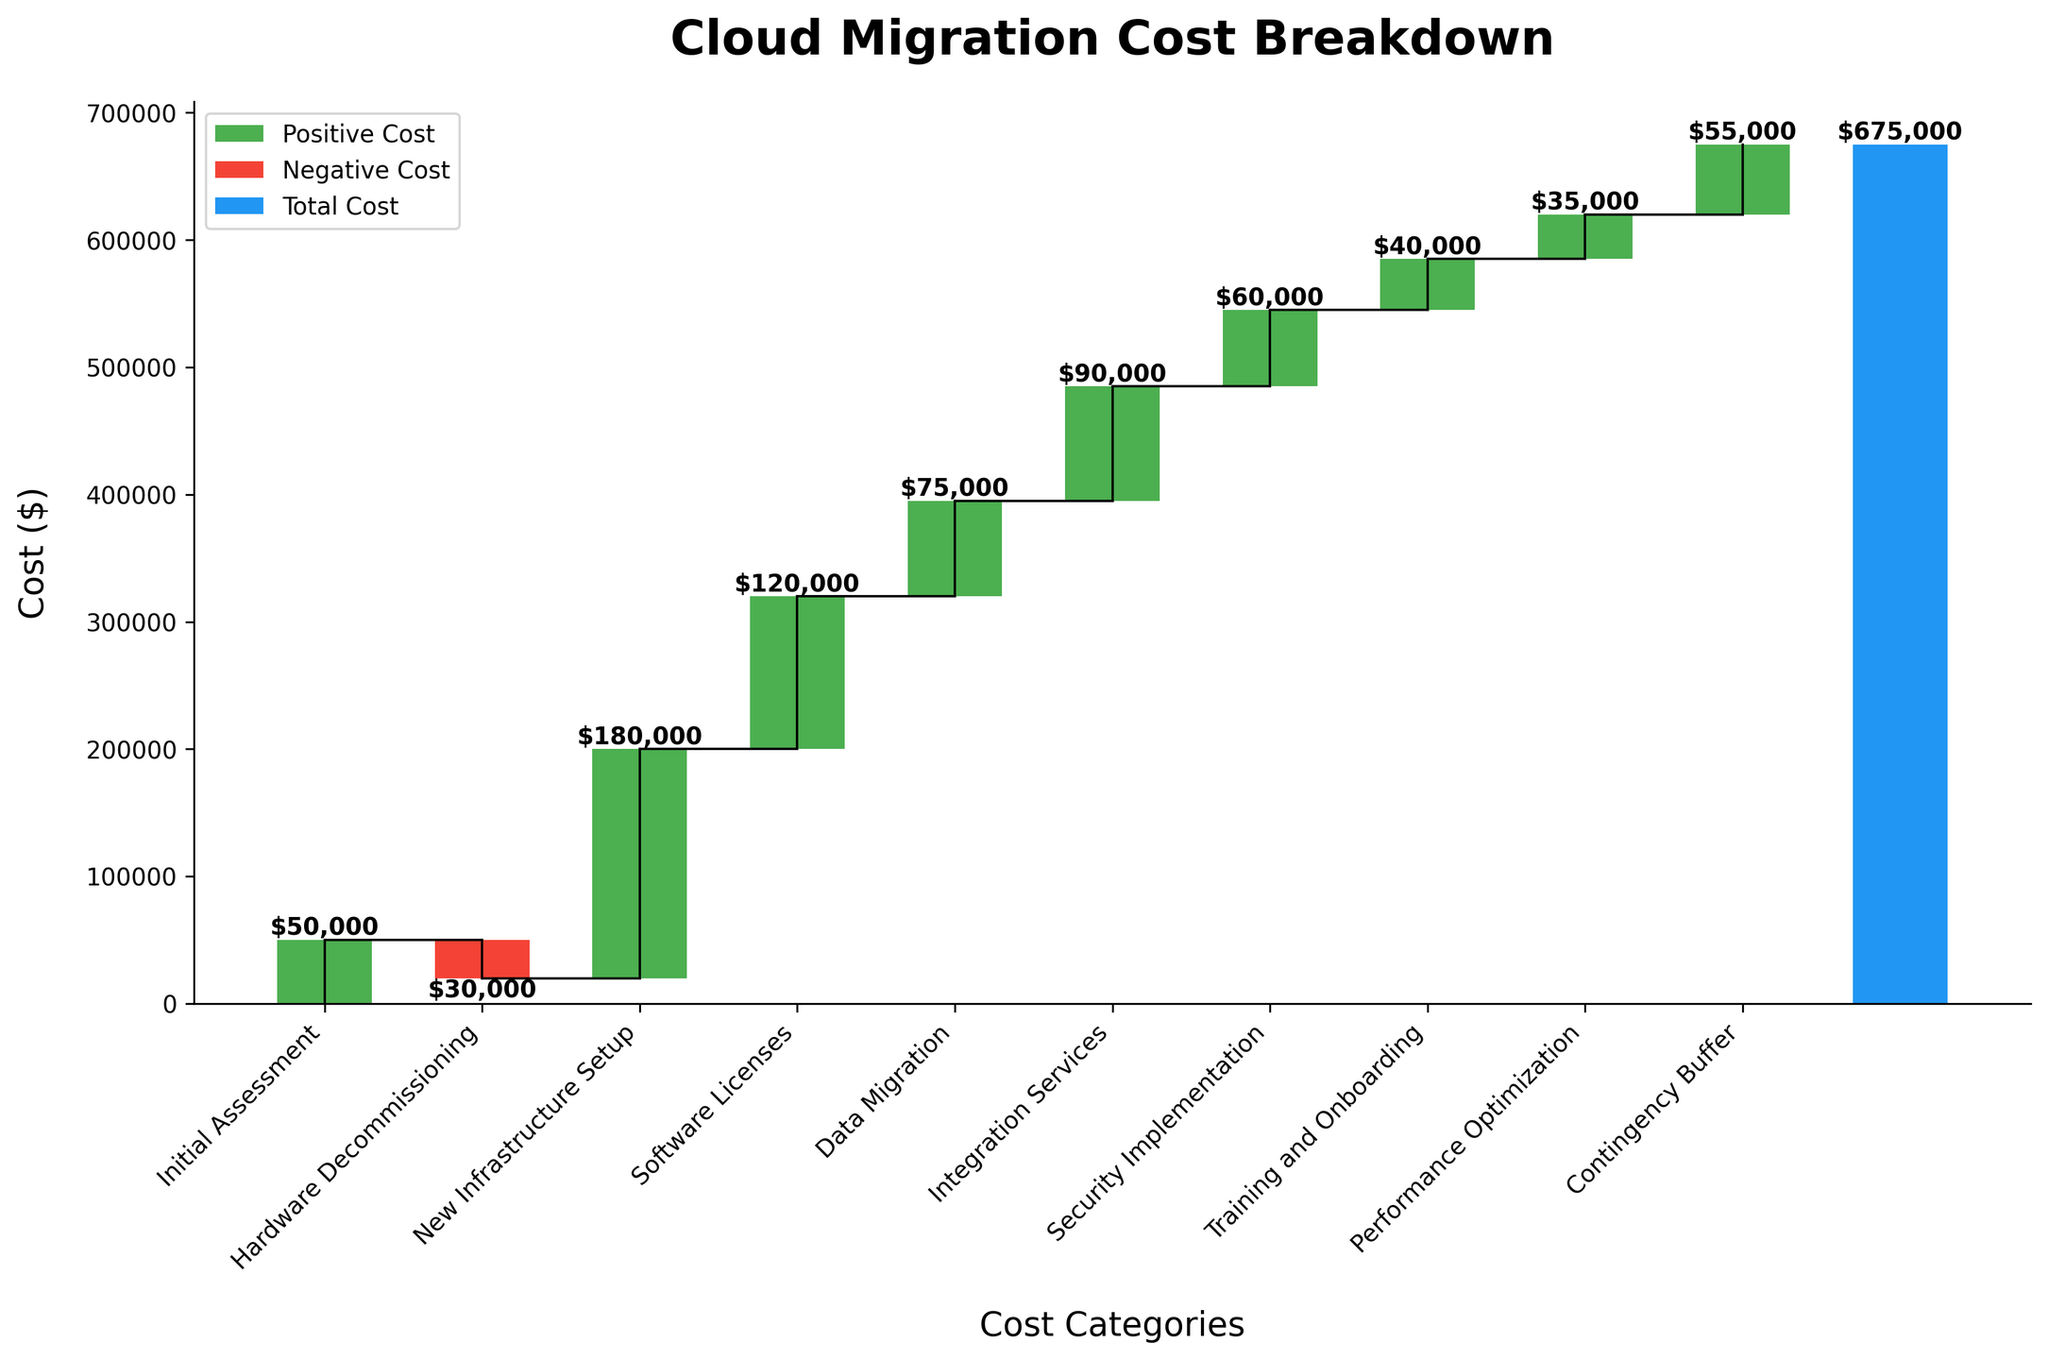What is the title of the chart? The title of the chart is written at the top and says 'Cloud Migration Cost Breakdown'.
Answer: Cloud Migration Cost Breakdown What is the value for the 'Software Licenses' category? The value for 'Software Licenses' can be found on the bar labeled 'Software Licenses'. It shows an amount of $120,000.
Answer: $120,000 Which category represents the largest positive cost? By comparing the bars, the 'New Infrastructure Setup' category has the highest positive value of $180,000.
Answer: New Infrastructure Setup How many categories contribute to the total cost excluding the total? By counting the bars on the x-axis, excluding the final 'Total Cloud Migration Cost', there are nine categories.
Answer: 9 What is the cumulative total after 'Data Migration'? Summing up the values up to and including 'Data Migration' (-50000 + -30000 + 180000 + 120000 + 75000 = 295000). Therefore, the cumulative total after 'Data Migration' is $295,000.
Answer: $295,000 What is the difference between 'Integration Services' and 'Training and Onboarding' costs? 'Integration Services' cost $90,000, and 'Training and Onboarding' cost $40,000. The difference is $90,000 - $40,000 = $50,000.
Answer: $50,000 How does 'Hardware Decommissioning' affect the total cost? 'Hardware Decommissioning' has a negative value of -$30,000, which decreases the total cost.
Answer: It decreases the total cost by $30,000 What color is used to represent positive costs in the chart? Positive costs are indicated by a green color in the chart.
Answer: Green What is the total cloud migration cost? The last bar represents the total cloud migration cost which is $675,000.
Answer: $675,000 Is the cost of 'Security Implementation' higher or lower than 'Performance Optimization'? 'Security Implementation' has a value of $60,000, whereas 'Performance Optimization' is $35,000. Therefore, 'Security Implementation' is higher.
Answer: Higher 